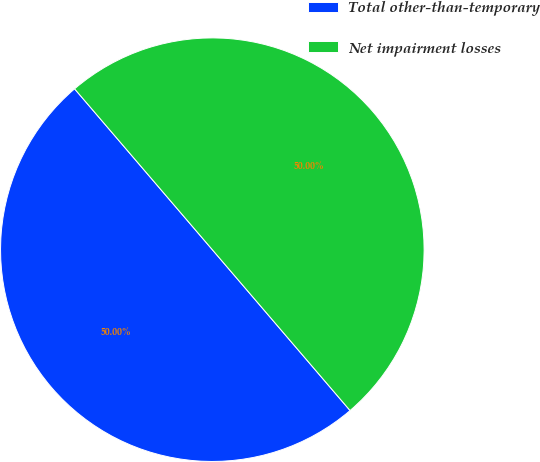<chart> <loc_0><loc_0><loc_500><loc_500><pie_chart><fcel>Total other-than-temporary<fcel>Net impairment losses<nl><fcel>50.0%<fcel>50.0%<nl></chart> 